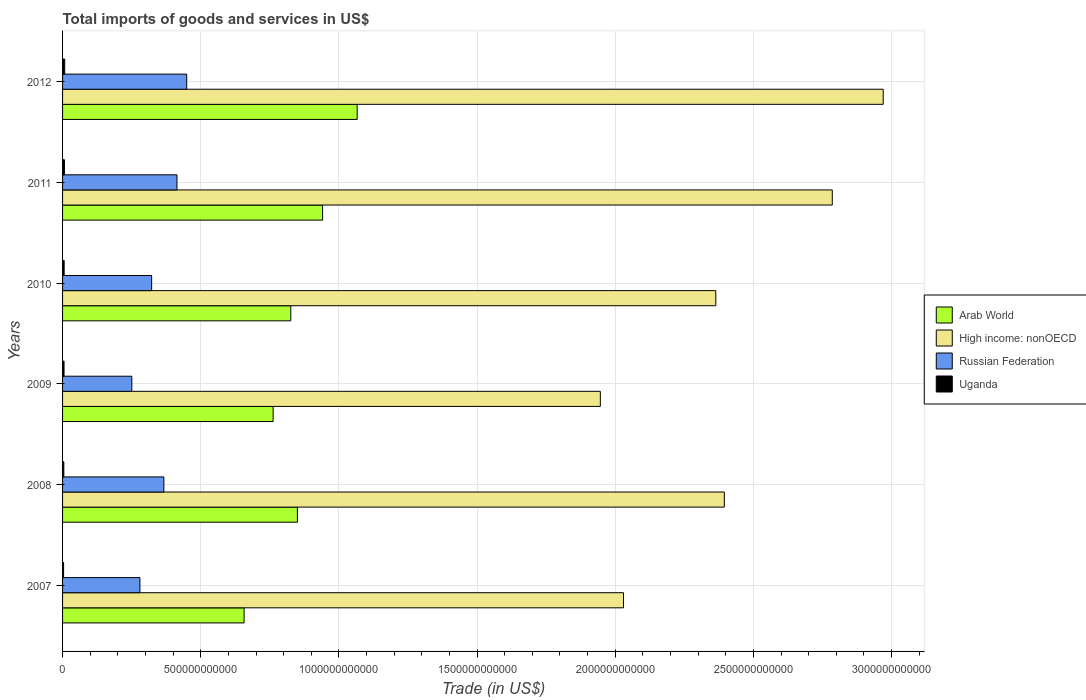How many different coloured bars are there?
Offer a terse response. 4. Are the number of bars per tick equal to the number of legend labels?
Your response must be concise. Yes. Are the number of bars on each tick of the Y-axis equal?
Ensure brevity in your answer.  Yes. How many bars are there on the 1st tick from the top?
Your answer should be very brief. 4. What is the label of the 1st group of bars from the top?
Provide a short and direct response. 2012. What is the total imports of goods and services in High income: nonOECD in 2009?
Provide a succinct answer. 1.95e+12. Across all years, what is the maximum total imports of goods and services in High income: nonOECD?
Make the answer very short. 2.97e+12. Across all years, what is the minimum total imports of goods and services in Russian Federation?
Offer a very short reply. 2.51e+11. In which year was the total imports of goods and services in Russian Federation maximum?
Your answer should be compact. 2012. What is the total total imports of goods and services in Arab World in the graph?
Your response must be concise. 5.10e+12. What is the difference between the total imports of goods and services in Arab World in 2007 and that in 2008?
Provide a short and direct response. -1.93e+11. What is the difference between the total imports of goods and services in High income: nonOECD in 2011 and the total imports of goods and services in Uganda in 2008?
Make the answer very short. 2.78e+12. What is the average total imports of goods and services in Uganda per year?
Offer a very short reply. 5.64e+09. In the year 2012, what is the difference between the total imports of goods and services in Arab World and total imports of goods and services in High income: nonOECD?
Make the answer very short. -1.90e+12. What is the ratio of the total imports of goods and services in Uganda in 2009 to that in 2012?
Keep it short and to the point. 0.7. Is the difference between the total imports of goods and services in Arab World in 2007 and 2010 greater than the difference between the total imports of goods and services in High income: nonOECD in 2007 and 2010?
Make the answer very short. Yes. What is the difference between the highest and the second highest total imports of goods and services in Russian Federation?
Offer a terse response. 3.52e+1. What is the difference between the highest and the lowest total imports of goods and services in High income: nonOECD?
Provide a succinct answer. 1.02e+12. What does the 4th bar from the top in 2008 represents?
Give a very brief answer. Arab World. What does the 1st bar from the bottom in 2008 represents?
Ensure brevity in your answer.  Arab World. Is it the case that in every year, the sum of the total imports of goods and services in High income: nonOECD and total imports of goods and services in Arab World is greater than the total imports of goods and services in Russian Federation?
Offer a very short reply. Yes. What is the difference between two consecutive major ticks on the X-axis?
Make the answer very short. 5.00e+11. Are the values on the major ticks of X-axis written in scientific E-notation?
Provide a short and direct response. No. How many legend labels are there?
Offer a very short reply. 4. How are the legend labels stacked?
Make the answer very short. Vertical. What is the title of the graph?
Give a very brief answer. Total imports of goods and services in US$. Does "Greece" appear as one of the legend labels in the graph?
Your response must be concise. No. What is the label or title of the X-axis?
Give a very brief answer. Trade (in US$). What is the label or title of the Y-axis?
Your response must be concise. Years. What is the Trade (in US$) of Arab World in 2007?
Your response must be concise. 6.57e+11. What is the Trade (in US$) of High income: nonOECD in 2007?
Your answer should be very brief. 2.03e+12. What is the Trade (in US$) in Russian Federation in 2007?
Offer a very short reply. 2.80e+11. What is the Trade (in US$) in Uganda in 2007?
Your answer should be very brief. 3.69e+09. What is the Trade (in US$) of Arab World in 2008?
Your answer should be very brief. 8.50e+11. What is the Trade (in US$) in High income: nonOECD in 2008?
Keep it short and to the point. 2.39e+12. What is the Trade (in US$) in Russian Federation in 2008?
Give a very brief answer. 3.67e+11. What is the Trade (in US$) of Uganda in 2008?
Keep it short and to the point. 4.55e+09. What is the Trade (in US$) in Arab World in 2009?
Give a very brief answer. 7.62e+11. What is the Trade (in US$) of High income: nonOECD in 2009?
Give a very brief answer. 1.95e+12. What is the Trade (in US$) of Russian Federation in 2009?
Provide a short and direct response. 2.51e+11. What is the Trade (in US$) in Uganda in 2009?
Provide a succinct answer. 5.34e+09. What is the Trade (in US$) in Arab World in 2010?
Give a very brief answer. 8.26e+11. What is the Trade (in US$) in High income: nonOECD in 2010?
Ensure brevity in your answer.  2.36e+12. What is the Trade (in US$) in Russian Federation in 2010?
Make the answer very short. 3.22e+11. What is the Trade (in US$) in Uganda in 2010?
Provide a succinct answer. 5.77e+09. What is the Trade (in US$) in Arab World in 2011?
Your answer should be compact. 9.41e+11. What is the Trade (in US$) of High income: nonOECD in 2011?
Give a very brief answer. 2.79e+12. What is the Trade (in US$) of Russian Federation in 2011?
Your answer should be very brief. 4.14e+11. What is the Trade (in US$) of Uganda in 2011?
Your answer should be compact. 6.84e+09. What is the Trade (in US$) in Arab World in 2012?
Your answer should be very brief. 1.07e+12. What is the Trade (in US$) in High income: nonOECD in 2012?
Ensure brevity in your answer.  2.97e+12. What is the Trade (in US$) in Russian Federation in 2012?
Your response must be concise. 4.49e+11. What is the Trade (in US$) in Uganda in 2012?
Provide a succinct answer. 7.66e+09. Across all years, what is the maximum Trade (in US$) in Arab World?
Your answer should be very brief. 1.07e+12. Across all years, what is the maximum Trade (in US$) in High income: nonOECD?
Keep it short and to the point. 2.97e+12. Across all years, what is the maximum Trade (in US$) of Russian Federation?
Your answer should be compact. 4.49e+11. Across all years, what is the maximum Trade (in US$) of Uganda?
Your answer should be very brief. 7.66e+09. Across all years, what is the minimum Trade (in US$) of Arab World?
Give a very brief answer. 6.57e+11. Across all years, what is the minimum Trade (in US$) in High income: nonOECD?
Ensure brevity in your answer.  1.95e+12. Across all years, what is the minimum Trade (in US$) in Russian Federation?
Your answer should be very brief. 2.51e+11. Across all years, what is the minimum Trade (in US$) in Uganda?
Offer a terse response. 3.69e+09. What is the total Trade (in US$) of Arab World in the graph?
Offer a terse response. 5.10e+12. What is the total Trade (in US$) of High income: nonOECD in the graph?
Ensure brevity in your answer.  1.45e+13. What is the total Trade (in US$) in Russian Federation in the graph?
Your response must be concise. 2.08e+12. What is the total Trade (in US$) in Uganda in the graph?
Your response must be concise. 3.39e+1. What is the difference between the Trade (in US$) of Arab World in 2007 and that in 2008?
Keep it short and to the point. -1.93e+11. What is the difference between the Trade (in US$) in High income: nonOECD in 2007 and that in 2008?
Keep it short and to the point. -3.65e+11. What is the difference between the Trade (in US$) of Russian Federation in 2007 and that in 2008?
Keep it short and to the point. -8.66e+1. What is the difference between the Trade (in US$) in Uganda in 2007 and that in 2008?
Provide a succinct answer. -8.59e+08. What is the difference between the Trade (in US$) in Arab World in 2007 and that in 2009?
Give a very brief answer. -1.05e+11. What is the difference between the Trade (in US$) of High income: nonOECD in 2007 and that in 2009?
Provide a short and direct response. 8.38e+1. What is the difference between the Trade (in US$) in Russian Federation in 2007 and that in 2009?
Offer a terse response. 2.94e+1. What is the difference between the Trade (in US$) in Uganda in 2007 and that in 2009?
Provide a succinct answer. -1.65e+09. What is the difference between the Trade (in US$) of Arab World in 2007 and that in 2010?
Ensure brevity in your answer.  -1.69e+11. What is the difference between the Trade (in US$) in High income: nonOECD in 2007 and that in 2010?
Make the answer very short. -3.34e+11. What is the difference between the Trade (in US$) in Russian Federation in 2007 and that in 2010?
Ensure brevity in your answer.  -4.24e+1. What is the difference between the Trade (in US$) of Uganda in 2007 and that in 2010?
Offer a terse response. -2.08e+09. What is the difference between the Trade (in US$) of Arab World in 2007 and that in 2011?
Keep it short and to the point. -2.84e+11. What is the difference between the Trade (in US$) of High income: nonOECD in 2007 and that in 2011?
Your answer should be compact. -7.55e+11. What is the difference between the Trade (in US$) in Russian Federation in 2007 and that in 2011?
Make the answer very short. -1.34e+11. What is the difference between the Trade (in US$) of Uganda in 2007 and that in 2011?
Ensure brevity in your answer.  -3.15e+09. What is the difference between the Trade (in US$) in Arab World in 2007 and that in 2012?
Provide a succinct answer. -4.09e+11. What is the difference between the Trade (in US$) in High income: nonOECD in 2007 and that in 2012?
Keep it short and to the point. -9.40e+11. What is the difference between the Trade (in US$) of Russian Federation in 2007 and that in 2012?
Your answer should be very brief. -1.69e+11. What is the difference between the Trade (in US$) in Uganda in 2007 and that in 2012?
Keep it short and to the point. -3.97e+09. What is the difference between the Trade (in US$) in Arab World in 2008 and that in 2009?
Keep it short and to the point. 8.78e+1. What is the difference between the Trade (in US$) in High income: nonOECD in 2008 and that in 2009?
Your answer should be very brief. 4.49e+11. What is the difference between the Trade (in US$) of Russian Federation in 2008 and that in 2009?
Provide a succinct answer. 1.16e+11. What is the difference between the Trade (in US$) in Uganda in 2008 and that in 2009?
Provide a succinct answer. -7.90e+08. What is the difference between the Trade (in US$) in Arab World in 2008 and that in 2010?
Provide a succinct answer. 2.39e+1. What is the difference between the Trade (in US$) of High income: nonOECD in 2008 and that in 2010?
Keep it short and to the point. 3.08e+1. What is the difference between the Trade (in US$) of Russian Federation in 2008 and that in 2010?
Make the answer very short. 4.42e+1. What is the difference between the Trade (in US$) in Uganda in 2008 and that in 2010?
Offer a very short reply. -1.22e+09. What is the difference between the Trade (in US$) of Arab World in 2008 and that in 2011?
Give a very brief answer. -9.12e+1. What is the difference between the Trade (in US$) of High income: nonOECD in 2008 and that in 2011?
Your answer should be compact. -3.91e+11. What is the difference between the Trade (in US$) of Russian Federation in 2008 and that in 2011?
Your answer should be compact. -4.74e+1. What is the difference between the Trade (in US$) of Uganda in 2008 and that in 2011?
Your answer should be very brief. -2.29e+09. What is the difference between the Trade (in US$) of Arab World in 2008 and that in 2012?
Your answer should be compact. -2.16e+11. What is the difference between the Trade (in US$) in High income: nonOECD in 2008 and that in 2012?
Provide a succinct answer. -5.75e+11. What is the difference between the Trade (in US$) of Russian Federation in 2008 and that in 2012?
Keep it short and to the point. -8.26e+1. What is the difference between the Trade (in US$) in Uganda in 2008 and that in 2012?
Give a very brief answer. -3.11e+09. What is the difference between the Trade (in US$) in Arab World in 2009 and that in 2010?
Give a very brief answer. -6.40e+1. What is the difference between the Trade (in US$) of High income: nonOECD in 2009 and that in 2010?
Your answer should be compact. -4.18e+11. What is the difference between the Trade (in US$) in Russian Federation in 2009 and that in 2010?
Your response must be concise. -7.18e+1. What is the difference between the Trade (in US$) in Uganda in 2009 and that in 2010?
Provide a short and direct response. -4.27e+08. What is the difference between the Trade (in US$) in Arab World in 2009 and that in 2011?
Make the answer very short. -1.79e+11. What is the difference between the Trade (in US$) of High income: nonOECD in 2009 and that in 2011?
Make the answer very short. -8.39e+11. What is the difference between the Trade (in US$) of Russian Federation in 2009 and that in 2011?
Offer a terse response. -1.63e+11. What is the difference between the Trade (in US$) of Uganda in 2009 and that in 2011?
Ensure brevity in your answer.  -1.50e+09. What is the difference between the Trade (in US$) of Arab World in 2009 and that in 2012?
Ensure brevity in your answer.  -3.04e+11. What is the difference between the Trade (in US$) in High income: nonOECD in 2009 and that in 2012?
Make the answer very short. -1.02e+12. What is the difference between the Trade (in US$) in Russian Federation in 2009 and that in 2012?
Your response must be concise. -1.99e+11. What is the difference between the Trade (in US$) of Uganda in 2009 and that in 2012?
Provide a short and direct response. -2.32e+09. What is the difference between the Trade (in US$) in Arab World in 2010 and that in 2011?
Your answer should be very brief. -1.15e+11. What is the difference between the Trade (in US$) in High income: nonOECD in 2010 and that in 2011?
Ensure brevity in your answer.  -4.21e+11. What is the difference between the Trade (in US$) in Russian Federation in 2010 and that in 2011?
Keep it short and to the point. -9.16e+1. What is the difference between the Trade (in US$) in Uganda in 2010 and that in 2011?
Offer a terse response. -1.07e+09. What is the difference between the Trade (in US$) of Arab World in 2010 and that in 2012?
Offer a terse response. -2.40e+11. What is the difference between the Trade (in US$) of High income: nonOECD in 2010 and that in 2012?
Keep it short and to the point. -6.06e+11. What is the difference between the Trade (in US$) of Russian Federation in 2010 and that in 2012?
Your answer should be very brief. -1.27e+11. What is the difference between the Trade (in US$) in Uganda in 2010 and that in 2012?
Make the answer very short. -1.89e+09. What is the difference between the Trade (in US$) in Arab World in 2011 and that in 2012?
Your response must be concise. -1.25e+11. What is the difference between the Trade (in US$) of High income: nonOECD in 2011 and that in 2012?
Give a very brief answer. -1.84e+11. What is the difference between the Trade (in US$) in Russian Federation in 2011 and that in 2012?
Your answer should be very brief. -3.52e+1. What is the difference between the Trade (in US$) of Uganda in 2011 and that in 2012?
Your response must be concise. -8.18e+08. What is the difference between the Trade (in US$) of Arab World in 2007 and the Trade (in US$) of High income: nonOECD in 2008?
Provide a short and direct response. -1.74e+12. What is the difference between the Trade (in US$) in Arab World in 2007 and the Trade (in US$) in Russian Federation in 2008?
Keep it short and to the point. 2.90e+11. What is the difference between the Trade (in US$) of Arab World in 2007 and the Trade (in US$) of Uganda in 2008?
Give a very brief answer. 6.52e+11. What is the difference between the Trade (in US$) of High income: nonOECD in 2007 and the Trade (in US$) of Russian Federation in 2008?
Your response must be concise. 1.66e+12. What is the difference between the Trade (in US$) in High income: nonOECD in 2007 and the Trade (in US$) in Uganda in 2008?
Your answer should be compact. 2.03e+12. What is the difference between the Trade (in US$) of Russian Federation in 2007 and the Trade (in US$) of Uganda in 2008?
Your response must be concise. 2.75e+11. What is the difference between the Trade (in US$) in Arab World in 2007 and the Trade (in US$) in High income: nonOECD in 2009?
Your response must be concise. -1.29e+12. What is the difference between the Trade (in US$) of Arab World in 2007 and the Trade (in US$) of Russian Federation in 2009?
Your response must be concise. 4.06e+11. What is the difference between the Trade (in US$) in Arab World in 2007 and the Trade (in US$) in Uganda in 2009?
Offer a terse response. 6.52e+11. What is the difference between the Trade (in US$) of High income: nonOECD in 2007 and the Trade (in US$) of Russian Federation in 2009?
Ensure brevity in your answer.  1.78e+12. What is the difference between the Trade (in US$) in High income: nonOECD in 2007 and the Trade (in US$) in Uganda in 2009?
Give a very brief answer. 2.02e+12. What is the difference between the Trade (in US$) in Russian Federation in 2007 and the Trade (in US$) in Uganda in 2009?
Your response must be concise. 2.75e+11. What is the difference between the Trade (in US$) in Arab World in 2007 and the Trade (in US$) in High income: nonOECD in 2010?
Provide a succinct answer. -1.71e+12. What is the difference between the Trade (in US$) of Arab World in 2007 and the Trade (in US$) of Russian Federation in 2010?
Provide a succinct answer. 3.35e+11. What is the difference between the Trade (in US$) in Arab World in 2007 and the Trade (in US$) in Uganda in 2010?
Ensure brevity in your answer.  6.51e+11. What is the difference between the Trade (in US$) of High income: nonOECD in 2007 and the Trade (in US$) of Russian Federation in 2010?
Offer a terse response. 1.71e+12. What is the difference between the Trade (in US$) in High income: nonOECD in 2007 and the Trade (in US$) in Uganda in 2010?
Your response must be concise. 2.02e+12. What is the difference between the Trade (in US$) in Russian Federation in 2007 and the Trade (in US$) in Uganda in 2010?
Provide a short and direct response. 2.74e+11. What is the difference between the Trade (in US$) of Arab World in 2007 and the Trade (in US$) of High income: nonOECD in 2011?
Offer a very short reply. -2.13e+12. What is the difference between the Trade (in US$) in Arab World in 2007 and the Trade (in US$) in Russian Federation in 2011?
Your response must be concise. 2.43e+11. What is the difference between the Trade (in US$) in Arab World in 2007 and the Trade (in US$) in Uganda in 2011?
Ensure brevity in your answer.  6.50e+11. What is the difference between the Trade (in US$) of High income: nonOECD in 2007 and the Trade (in US$) of Russian Federation in 2011?
Ensure brevity in your answer.  1.62e+12. What is the difference between the Trade (in US$) of High income: nonOECD in 2007 and the Trade (in US$) of Uganda in 2011?
Give a very brief answer. 2.02e+12. What is the difference between the Trade (in US$) in Russian Federation in 2007 and the Trade (in US$) in Uganda in 2011?
Make the answer very short. 2.73e+11. What is the difference between the Trade (in US$) of Arab World in 2007 and the Trade (in US$) of High income: nonOECD in 2012?
Your answer should be very brief. -2.31e+12. What is the difference between the Trade (in US$) of Arab World in 2007 and the Trade (in US$) of Russian Federation in 2012?
Make the answer very short. 2.08e+11. What is the difference between the Trade (in US$) of Arab World in 2007 and the Trade (in US$) of Uganda in 2012?
Your response must be concise. 6.49e+11. What is the difference between the Trade (in US$) of High income: nonOECD in 2007 and the Trade (in US$) of Russian Federation in 2012?
Provide a succinct answer. 1.58e+12. What is the difference between the Trade (in US$) of High income: nonOECD in 2007 and the Trade (in US$) of Uganda in 2012?
Keep it short and to the point. 2.02e+12. What is the difference between the Trade (in US$) of Russian Federation in 2007 and the Trade (in US$) of Uganda in 2012?
Your answer should be compact. 2.72e+11. What is the difference between the Trade (in US$) of Arab World in 2008 and the Trade (in US$) of High income: nonOECD in 2009?
Provide a short and direct response. -1.10e+12. What is the difference between the Trade (in US$) in Arab World in 2008 and the Trade (in US$) in Russian Federation in 2009?
Your answer should be very brief. 5.99e+11. What is the difference between the Trade (in US$) of Arab World in 2008 and the Trade (in US$) of Uganda in 2009?
Offer a terse response. 8.44e+11. What is the difference between the Trade (in US$) of High income: nonOECD in 2008 and the Trade (in US$) of Russian Federation in 2009?
Offer a very short reply. 2.14e+12. What is the difference between the Trade (in US$) in High income: nonOECD in 2008 and the Trade (in US$) in Uganda in 2009?
Your answer should be compact. 2.39e+12. What is the difference between the Trade (in US$) in Russian Federation in 2008 and the Trade (in US$) in Uganda in 2009?
Provide a succinct answer. 3.61e+11. What is the difference between the Trade (in US$) of Arab World in 2008 and the Trade (in US$) of High income: nonOECD in 2010?
Your response must be concise. -1.51e+12. What is the difference between the Trade (in US$) in Arab World in 2008 and the Trade (in US$) in Russian Federation in 2010?
Your response must be concise. 5.27e+11. What is the difference between the Trade (in US$) of Arab World in 2008 and the Trade (in US$) of Uganda in 2010?
Provide a succinct answer. 8.44e+11. What is the difference between the Trade (in US$) in High income: nonOECD in 2008 and the Trade (in US$) in Russian Federation in 2010?
Ensure brevity in your answer.  2.07e+12. What is the difference between the Trade (in US$) of High income: nonOECD in 2008 and the Trade (in US$) of Uganda in 2010?
Provide a short and direct response. 2.39e+12. What is the difference between the Trade (in US$) in Russian Federation in 2008 and the Trade (in US$) in Uganda in 2010?
Provide a short and direct response. 3.61e+11. What is the difference between the Trade (in US$) of Arab World in 2008 and the Trade (in US$) of High income: nonOECD in 2011?
Your response must be concise. -1.94e+12. What is the difference between the Trade (in US$) in Arab World in 2008 and the Trade (in US$) in Russian Federation in 2011?
Your response must be concise. 4.36e+11. What is the difference between the Trade (in US$) of Arab World in 2008 and the Trade (in US$) of Uganda in 2011?
Make the answer very short. 8.43e+11. What is the difference between the Trade (in US$) of High income: nonOECD in 2008 and the Trade (in US$) of Russian Federation in 2011?
Provide a succinct answer. 1.98e+12. What is the difference between the Trade (in US$) of High income: nonOECD in 2008 and the Trade (in US$) of Uganda in 2011?
Offer a terse response. 2.39e+12. What is the difference between the Trade (in US$) of Russian Federation in 2008 and the Trade (in US$) of Uganda in 2011?
Provide a succinct answer. 3.60e+11. What is the difference between the Trade (in US$) in Arab World in 2008 and the Trade (in US$) in High income: nonOECD in 2012?
Provide a short and direct response. -2.12e+12. What is the difference between the Trade (in US$) of Arab World in 2008 and the Trade (in US$) of Russian Federation in 2012?
Provide a succinct answer. 4.01e+11. What is the difference between the Trade (in US$) in Arab World in 2008 and the Trade (in US$) in Uganda in 2012?
Ensure brevity in your answer.  8.42e+11. What is the difference between the Trade (in US$) of High income: nonOECD in 2008 and the Trade (in US$) of Russian Federation in 2012?
Offer a very short reply. 1.95e+12. What is the difference between the Trade (in US$) in High income: nonOECD in 2008 and the Trade (in US$) in Uganda in 2012?
Offer a very short reply. 2.39e+12. What is the difference between the Trade (in US$) of Russian Federation in 2008 and the Trade (in US$) of Uganda in 2012?
Offer a terse response. 3.59e+11. What is the difference between the Trade (in US$) of Arab World in 2009 and the Trade (in US$) of High income: nonOECD in 2010?
Make the answer very short. -1.60e+12. What is the difference between the Trade (in US$) of Arab World in 2009 and the Trade (in US$) of Russian Federation in 2010?
Keep it short and to the point. 4.40e+11. What is the difference between the Trade (in US$) in Arab World in 2009 and the Trade (in US$) in Uganda in 2010?
Offer a very short reply. 7.56e+11. What is the difference between the Trade (in US$) in High income: nonOECD in 2009 and the Trade (in US$) in Russian Federation in 2010?
Your answer should be very brief. 1.62e+12. What is the difference between the Trade (in US$) of High income: nonOECD in 2009 and the Trade (in US$) of Uganda in 2010?
Give a very brief answer. 1.94e+12. What is the difference between the Trade (in US$) of Russian Federation in 2009 and the Trade (in US$) of Uganda in 2010?
Your response must be concise. 2.45e+11. What is the difference between the Trade (in US$) of Arab World in 2009 and the Trade (in US$) of High income: nonOECD in 2011?
Your answer should be compact. -2.02e+12. What is the difference between the Trade (in US$) in Arab World in 2009 and the Trade (in US$) in Russian Federation in 2011?
Make the answer very short. 3.48e+11. What is the difference between the Trade (in US$) in Arab World in 2009 and the Trade (in US$) in Uganda in 2011?
Offer a very short reply. 7.55e+11. What is the difference between the Trade (in US$) of High income: nonOECD in 2009 and the Trade (in US$) of Russian Federation in 2011?
Ensure brevity in your answer.  1.53e+12. What is the difference between the Trade (in US$) of High income: nonOECD in 2009 and the Trade (in US$) of Uganda in 2011?
Your response must be concise. 1.94e+12. What is the difference between the Trade (in US$) of Russian Federation in 2009 and the Trade (in US$) of Uganda in 2011?
Offer a very short reply. 2.44e+11. What is the difference between the Trade (in US$) in Arab World in 2009 and the Trade (in US$) in High income: nonOECD in 2012?
Make the answer very short. -2.21e+12. What is the difference between the Trade (in US$) of Arab World in 2009 and the Trade (in US$) of Russian Federation in 2012?
Provide a succinct answer. 3.13e+11. What is the difference between the Trade (in US$) in Arab World in 2009 and the Trade (in US$) in Uganda in 2012?
Ensure brevity in your answer.  7.54e+11. What is the difference between the Trade (in US$) of High income: nonOECD in 2009 and the Trade (in US$) of Russian Federation in 2012?
Give a very brief answer. 1.50e+12. What is the difference between the Trade (in US$) in High income: nonOECD in 2009 and the Trade (in US$) in Uganda in 2012?
Give a very brief answer. 1.94e+12. What is the difference between the Trade (in US$) of Russian Federation in 2009 and the Trade (in US$) of Uganda in 2012?
Ensure brevity in your answer.  2.43e+11. What is the difference between the Trade (in US$) of Arab World in 2010 and the Trade (in US$) of High income: nonOECD in 2011?
Keep it short and to the point. -1.96e+12. What is the difference between the Trade (in US$) in Arab World in 2010 and the Trade (in US$) in Russian Federation in 2011?
Offer a terse response. 4.12e+11. What is the difference between the Trade (in US$) in Arab World in 2010 and the Trade (in US$) in Uganda in 2011?
Offer a terse response. 8.19e+11. What is the difference between the Trade (in US$) in High income: nonOECD in 2010 and the Trade (in US$) in Russian Federation in 2011?
Ensure brevity in your answer.  1.95e+12. What is the difference between the Trade (in US$) of High income: nonOECD in 2010 and the Trade (in US$) of Uganda in 2011?
Provide a short and direct response. 2.36e+12. What is the difference between the Trade (in US$) in Russian Federation in 2010 and the Trade (in US$) in Uganda in 2011?
Your answer should be compact. 3.16e+11. What is the difference between the Trade (in US$) of Arab World in 2010 and the Trade (in US$) of High income: nonOECD in 2012?
Offer a terse response. -2.14e+12. What is the difference between the Trade (in US$) of Arab World in 2010 and the Trade (in US$) of Russian Federation in 2012?
Your response must be concise. 3.77e+11. What is the difference between the Trade (in US$) of Arab World in 2010 and the Trade (in US$) of Uganda in 2012?
Make the answer very short. 8.18e+11. What is the difference between the Trade (in US$) in High income: nonOECD in 2010 and the Trade (in US$) in Russian Federation in 2012?
Your response must be concise. 1.91e+12. What is the difference between the Trade (in US$) of High income: nonOECD in 2010 and the Trade (in US$) of Uganda in 2012?
Provide a succinct answer. 2.36e+12. What is the difference between the Trade (in US$) of Russian Federation in 2010 and the Trade (in US$) of Uganda in 2012?
Offer a very short reply. 3.15e+11. What is the difference between the Trade (in US$) of Arab World in 2011 and the Trade (in US$) of High income: nonOECD in 2012?
Your answer should be compact. -2.03e+12. What is the difference between the Trade (in US$) of Arab World in 2011 and the Trade (in US$) of Russian Federation in 2012?
Provide a succinct answer. 4.92e+11. What is the difference between the Trade (in US$) in Arab World in 2011 and the Trade (in US$) in Uganda in 2012?
Provide a short and direct response. 9.33e+11. What is the difference between the Trade (in US$) of High income: nonOECD in 2011 and the Trade (in US$) of Russian Federation in 2012?
Your response must be concise. 2.34e+12. What is the difference between the Trade (in US$) of High income: nonOECD in 2011 and the Trade (in US$) of Uganda in 2012?
Provide a succinct answer. 2.78e+12. What is the difference between the Trade (in US$) of Russian Federation in 2011 and the Trade (in US$) of Uganda in 2012?
Ensure brevity in your answer.  4.06e+11. What is the average Trade (in US$) of Arab World per year?
Provide a succinct answer. 8.50e+11. What is the average Trade (in US$) of High income: nonOECD per year?
Give a very brief answer. 2.42e+12. What is the average Trade (in US$) of Russian Federation per year?
Provide a short and direct response. 3.47e+11. What is the average Trade (in US$) of Uganda per year?
Give a very brief answer. 5.64e+09. In the year 2007, what is the difference between the Trade (in US$) in Arab World and Trade (in US$) in High income: nonOECD?
Provide a succinct answer. -1.37e+12. In the year 2007, what is the difference between the Trade (in US$) in Arab World and Trade (in US$) in Russian Federation?
Ensure brevity in your answer.  3.77e+11. In the year 2007, what is the difference between the Trade (in US$) in Arab World and Trade (in US$) in Uganda?
Your response must be concise. 6.53e+11. In the year 2007, what is the difference between the Trade (in US$) of High income: nonOECD and Trade (in US$) of Russian Federation?
Your answer should be very brief. 1.75e+12. In the year 2007, what is the difference between the Trade (in US$) in High income: nonOECD and Trade (in US$) in Uganda?
Your answer should be compact. 2.03e+12. In the year 2007, what is the difference between the Trade (in US$) of Russian Federation and Trade (in US$) of Uganda?
Provide a succinct answer. 2.76e+11. In the year 2008, what is the difference between the Trade (in US$) of Arab World and Trade (in US$) of High income: nonOECD?
Offer a terse response. -1.54e+12. In the year 2008, what is the difference between the Trade (in US$) in Arab World and Trade (in US$) in Russian Federation?
Ensure brevity in your answer.  4.83e+11. In the year 2008, what is the difference between the Trade (in US$) in Arab World and Trade (in US$) in Uganda?
Ensure brevity in your answer.  8.45e+11. In the year 2008, what is the difference between the Trade (in US$) of High income: nonOECD and Trade (in US$) of Russian Federation?
Keep it short and to the point. 2.03e+12. In the year 2008, what is the difference between the Trade (in US$) of High income: nonOECD and Trade (in US$) of Uganda?
Ensure brevity in your answer.  2.39e+12. In the year 2008, what is the difference between the Trade (in US$) of Russian Federation and Trade (in US$) of Uganda?
Make the answer very short. 3.62e+11. In the year 2009, what is the difference between the Trade (in US$) of Arab World and Trade (in US$) of High income: nonOECD?
Keep it short and to the point. -1.18e+12. In the year 2009, what is the difference between the Trade (in US$) of Arab World and Trade (in US$) of Russian Federation?
Offer a terse response. 5.11e+11. In the year 2009, what is the difference between the Trade (in US$) in Arab World and Trade (in US$) in Uganda?
Your answer should be very brief. 7.57e+11. In the year 2009, what is the difference between the Trade (in US$) in High income: nonOECD and Trade (in US$) in Russian Federation?
Your response must be concise. 1.70e+12. In the year 2009, what is the difference between the Trade (in US$) in High income: nonOECD and Trade (in US$) in Uganda?
Make the answer very short. 1.94e+12. In the year 2009, what is the difference between the Trade (in US$) in Russian Federation and Trade (in US$) in Uganda?
Ensure brevity in your answer.  2.45e+11. In the year 2010, what is the difference between the Trade (in US$) in Arab World and Trade (in US$) in High income: nonOECD?
Ensure brevity in your answer.  -1.54e+12. In the year 2010, what is the difference between the Trade (in US$) of Arab World and Trade (in US$) of Russian Federation?
Provide a succinct answer. 5.04e+11. In the year 2010, what is the difference between the Trade (in US$) in Arab World and Trade (in US$) in Uganda?
Give a very brief answer. 8.20e+11. In the year 2010, what is the difference between the Trade (in US$) of High income: nonOECD and Trade (in US$) of Russian Federation?
Offer a terse response. 2.04e+12. In the year 2010, what is the difference between the Trade (in US$) of High income: nonOECD and Trade (in US$) of Uganda?
Offer a terse response. 2.36e+12. In the year 2010, what is the difference between the Trade (in US$) of Russian Federation and Trade (in US$) of Uganda?
Ensure brevity in your answer.  3.17e+11. In the year 2011, what is the difference between the Trade (in US$) of Arab World and Trade (in US$) of High income: nonOECD?
Offer a very short reply. -1.84e+12. In the year 2011, what is the difference between the Trade (in US$) of Arab World and Trade (in US$) of Russian Federation?
Give a very brief answer. 5.27e+11. In the year 2011, what is the difference between the Trade (in US$) of Arab World and Trade (in US$) of Uganda?
Ensure brevity in your answer.  9.34e+11. In the year 2011, what is the difference between the Trade (in US$) in High income: nonOECD and Trade (in US$) in Russian Federation?
Provide a succinct answer. 2.37e+12. In the year 2011, what is the difference between the Trade (in US$) of High income: nonOECD and Trade (in US$) of Uganda?
Your answer should be compact. 2.78e+12. In the year 2011, what is the difference between the Trade (in US$) in Russian Federation and Trade (in US$) in Uganda?
Keep it short and to the point. 4.07e+11. In the year 2012, what is the difference between the Trade (in US$) in Arab World and Trade (in US$) in High income: nonOECD?
Offer a very short reply. -1.90e+12. In the year 2012, what is the difference between the Trade (in US$) of Arab World and Trade (in US$) of Russian Federation?
Your answer should be very brief. 6.17e+11. In the year 2012, what is the difference between the Trade (in US$) in Arab World and Trade (in US$) in Uganda?
Make the answer very short. 1.06e+12. In the year 2012, what is the difference between the Trade (in US$) of High income: nonOECD and Trade (in US$) of Russian Federation?
Your answer should be very brief. 2.52e+12. In the year 2012, what is the difference between the Trade (in US$) in High income: nonOECD and Trade (in US$) in Uganda?
Offer a terse response. 2.96e+12. In the year 2012, what is the difference between the Trade (in US$) of Russian Federation and Trade (in US$) of Uganda?
Give a very brief answer. 4.42e+11. What is the ratio of the Trade (in US$) in Arab World in 2007 to that in 2008?
Your answer should be very brief. 0.77. What is the ratio of the Trade (in US$) in High income: nonOECD in 2007 to that in 2008?
Offer a terse response. 0.85. What is the ratio of the Trade (in US$) in Russian Federation in 2007 to that in 2008?
Provide a short and direct response. 0.76. What is the ratio of the Trade (in US$) of Uganda in 2007 to that in 2008?
Keep it short and to the point. 0.81. What is the ratio of the Trade (in US$) of Arab World in 2007 to that in 2009?
Your answer should be compact. 0.86. What is the ratio of the Trade (in US$) of High income: nonOECD in 2007 to that in 2009?
Offer a very short reply. 1.04. What is the ratio of the Trade (in US$) in Russian Federation in 2007 to that in 2009?
Offer a terse response. 1.12. What is the ratio of the Trade (in US$) of Uganda in 2007 to that in 2009?
Offer a terse response. 0.69. What is the ratio of the Trade (in US$) in Arab World in 2007 to that in 2010?
Give a very brief answer. 0.8. What is the ratio of the Trade (in US$) in High income: nonOECD in 2007 to that in 2010?
Keep it short and to the point. 0.86. What is the ratio of the Trade (in US$) of Russian Federation in 2007 to that in 2010?
Offer a very short reply. 0.87. What is the ratio of the Trade (in US$) of Uganda in 2007 to that in 2010?
Ensure brevity in your answer.  0.64. What is the ratio of the Trade (in US$) in Arab World in 2007 to that in 2011?
Give a very brief answer. 0.7. What is the ratio of the Trade (in US$) in High income: nonOECD in 2007 to that in 2011?
Provide a short and direct response. 0.73. What is the ratio of the Trade (in US$) in Russian Federation in 2007 to that in 2011?
Give a very brief answer. 0.68. What is the ratio of the Trade (in US$) in Uganda in 2007 to that in 2011?
Ensure brevity in your answer.  0.54. What is the ratio of the Trade (in US$) in Arab World in 2007 to that in 2012?
Give a very brief answer. 0.62. What is the ratio of the Trade (in US$) in High income: nonOECD in 2007 to that in 2012?
Ensure brevity in your answer.  0.68. What is the ratio of the Trade (in US$) of Russian Federation in 2007 to that in 2012?
Offer a very short reply. 0.62. What is the ratio of the Trade (in US$) of Uganda in 2007 to that in 2012?
Offer a terse response. 0.48. What is the ratio of the Trade (in US$) of Arab World in 2008 to that in 2009?
Your response must be concise. 1.12. What is the ratio of the Trade (in US$) in High income: nonOECD in 2008 to that in 2009?
Your response must be concise. 1.23. What is the ratio of the Trade (in US$) of Russian Federation in 2008 to that in 2009?
Your answer should be compact. 1.46. What is the ratio of the Trade (in US$) of Uganda in 2008 to that in 2009?
Provide a short and direct response. 0.85. What is the ratio of the Trade (in US$) of Arab World in 2008 to that in 2010?
Your response must be concise. 1.03. What is the ratio of the Trade (in US$) in High income: nonOECD in 2008 to that in 2010?
Provide a succinct answer. 1.01. What is the ratio of the Trade (in US$) of Russian Federation in 2008 to that in 2010?
Your answer should be very brief. 1.14. What is the ratio of the Trade (in US$) of Uganda in 2008 to that in 2010?
Your response must be concise. 0.79. What is the ratio of the Trade (in US$) in Arab World in 2008 to that in 2011?
Your answer should be compact. 0.9. What is the ratio of the Trade (in US$) in High income: nonOECD in 2008 to that in 2011?
Keep it short and to the point. 0.86. What is the ratio of the Trade (in US$) of Russian Federation in 2008 to that in 2011?
Your answer should be very brief. 0.89. What is the ratio of the Trade (in US$) of Uganda in 2008 to that in 2011?
Give a very brief answer. 0.67. What is the ratio of the Trade (in US$) of Arab World in 2008 to that in 2012?
Your answer should be compact. 0.8. What is the ratio of the Trade (in US$) of High income: nonOECD in 2008 to that in 2012?
Offer a terse response. 0.81. What is the ratio of the Trade (in US$) of Russian Federation in 2008 to that in 2012?
Your response must be concise. 0.82. What is the ratio of the Trade (in US$) of Uganda in 2008 to that in 2012?
Provide a short and direct response. 0.59. What is the ratio of the Trade (in US$) in Arab World in 2009 to that in 2010?
Ensure brevity in your answer.  0.92. What is the ratio of the Trade (in US$) in High income: nonOECD in 2009 to that in 2010?
Provide a succinct answer. 0.82. What is the ratio of the Trade (in US$) in Russian Federation in 2009 to that in 2010?
Keep it short and to the point. 0.78. What is the ratio of the Trade (in US$) in Uganda in 2009 to that in 2010?
Ensure brevity in your answer.  0.93. What is the ratio of the Trade (in US$) in Arab World in 2009 to that in 2011?
Offer a very short reply. 0.81. What is the ratio of the Trade (in US$) of High income: nonOECD in 2009 to that in 2011?
Ensure brevity in your answer.  0.7. What is the ratio of the Trade (in US$) of Russian Federation in 2009 to that in 2011?
Offer a very short reply. 0.61. What is the ratio of the Trade (in US$) of Uganda in 2009 to that in 2011?
Your response must be concise. 0.78. What is the ratio of the Trade (in US$) in Arab World in 2009 to that in 2012?
Ensure brevity in your answer.  0.71. What is the ratio of the Trade (in US$) in High income: nonOECD in 2009 to that in 2012?
Keep it short and to the point. 0.66. What is the ratio of the Trade (in US$) in Russian Federation in 2009 to that in 2012?
Your answer should be compact. 0.56. What is the ratio of the Trade (in US$) of Uganda in 2009 to that in 2012?
Offer a very short reply. 0.7. What is the ratio of the Trade (in US$) of Arab World in 2010 to that in 2011?
Provide a short and direct response. 0.88. What is the ratio of the Trade (in US$) in High income: nonOECD in 2010 to that in 2011?
Keep it short and to the point. 0.85. What is the ratio of the Trade (in US$) of Russian Federation in 2010 to that in 2011?
Your answer should be compact. 0.78. What is the ratio of the Trade (in US$) of Uganda in 2010 to that in 2011?
Offer a very short reply. 0.84. What is the ratio of the Trade (in US$) in Arab World in 2010 to that in 2012?
Your answer should be compact. 0.77. What is the ratio of the Trade (in US$) in High income: nonOECD in 2010 to that in 2012?
Keep it short and to the point. 0.8. What is the ratio of the Trade (in US$) of Russian Federation in 2010 to that in 2012?
Provide a succinct answer. 0.72. What is the ratio of the Trade (in US$) in Uganda in 2010 to that in 2012?
Your answer should be very brief. 0.75. What is the ratio of the Trade (in US$) in Arab World in 2011 to that in 2012?
Your answer should be very brief. 0.88. What is the ratio of the Trade (in US$) in High income: nonOECD in 2011 to that in 2012?
Keep it short and to the point. 0.94. What is the ratio of the Trade (in US$) in Russian Federation in 2011 to that in 2012?
Your answer should be compact. 0.92. What is the ratio of the Trade (in US$) in Uganda in 2011 to that in 2012?
Provide a short and direct response. 0.89. What is the difference between the highest and the second highest Trade (in US$) in Arab World?
Your answer should be very brief. 1.25e+11. What is the difference between the highest and the second highest Trade (in US$) of High income: nonOECD?
Provide a short and direct response. 1.84e+11. What is the difference between the highest and the second highest Trade (in US$) in Russian Federation?
Your answer should be very brief. 3.52e+1. What is the difference between the highest and the second highest Trade (in US$) of Uganda?
Your answer should be compact. 8.18e+08. What is the difference between the highest and the lowest Trade (in US$) in Arab World?
Your answer should be very brief. 4.09e+11. What is the difference between the highest and the lowest Trade (in US$) of High income: nonOECD?
Offer a terse response. 1.02e+12. What is the difference between the highest and the lowest Trade (in US$) in Russian Federation?
Your answer should be compact. 1.99e+11. What is the difference between the highest and the lowest Trade (in US$) of Uganda?
Offer a very short reply. 3.97e+09. 